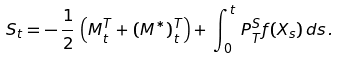<formula> <loc_0><loc_0><loc_500><loc_500>S _ { t } = - \, \frac { 1 } { 2 } \, \left ( M _ { t } ^ { T } + ( M ^ { * } ) _ { t } ^ { T } \right ) + \, \int _ { 0 } ^ { t } \, P _ { T } ^ { S } f ( X _ { s } ) \, d s \, .</formula> 